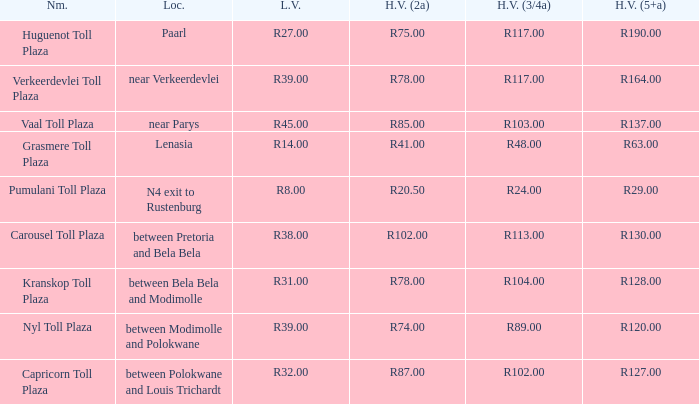What is the toll for light vehicles at the plaza where the toll for heavy vehicles with 2 axles is r87.00? R32.00. 